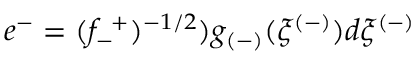<formula> <loc_0><loc_0><loc_500><loc_500>e ^ { - } = ( f _ { - } ^ { + } ) ^ { - 1 / 2 } ) g _ { ( - ) } ( \xi ^ { ( - ) } ) d \xi ^ { ( - ) }</formula> 